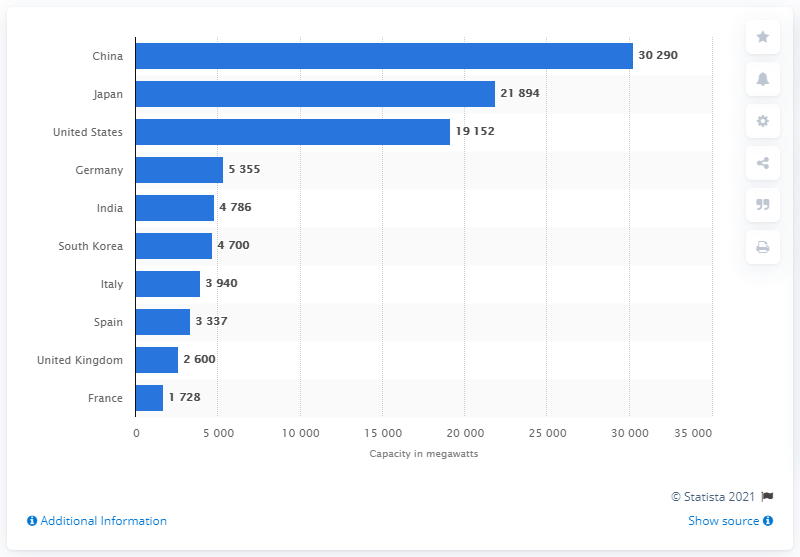Specify some key components in this picture. According to data from 2019, China was the country with the highest capacity of pumped storage hydropower. 